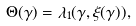<formula> <loc_0><loc_0><loc_500><loc_500>\Theta ( \gamma ) = \lambda _ { 1 } ( \gamma , \xi ( \gamma ) ) ,</formula> 